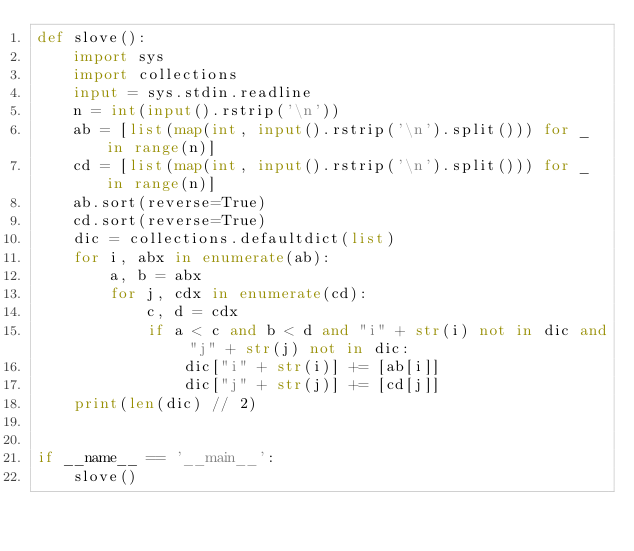Convert code to text. <code><loc_0><loc_0><loc_500><loc_500><_Python_>def slove():
    import sys
    import collections
    input = sys.stdin.readline
    n = int(input().rstrip('\n'))
    ab = [list(map(int, input().rstrip('\n').split())) for _ in range(n)]
    cd = [list(map(int, input().rstrip('\n').split())) for _ in range(n)]
    ab.sort(reverse=True)
    cd.sort(reverse=True)
    dic = collections.defaultdict(list)
    for i, abx in enumerate(ab):
        a, b = abx
        for j, cdx in enumerate(cd):
            c, d = cdx
            if a < c and b < d and "i" + str(i) not in dic and "j" + str(j) not in dic:
                dic["i" + str(i)] += [ab[i]]
                dic["j" + str(j)] += [cd[j]]
    print(len(dic) // 2)


if __name__ == '__main__':
    slove()
</code> 